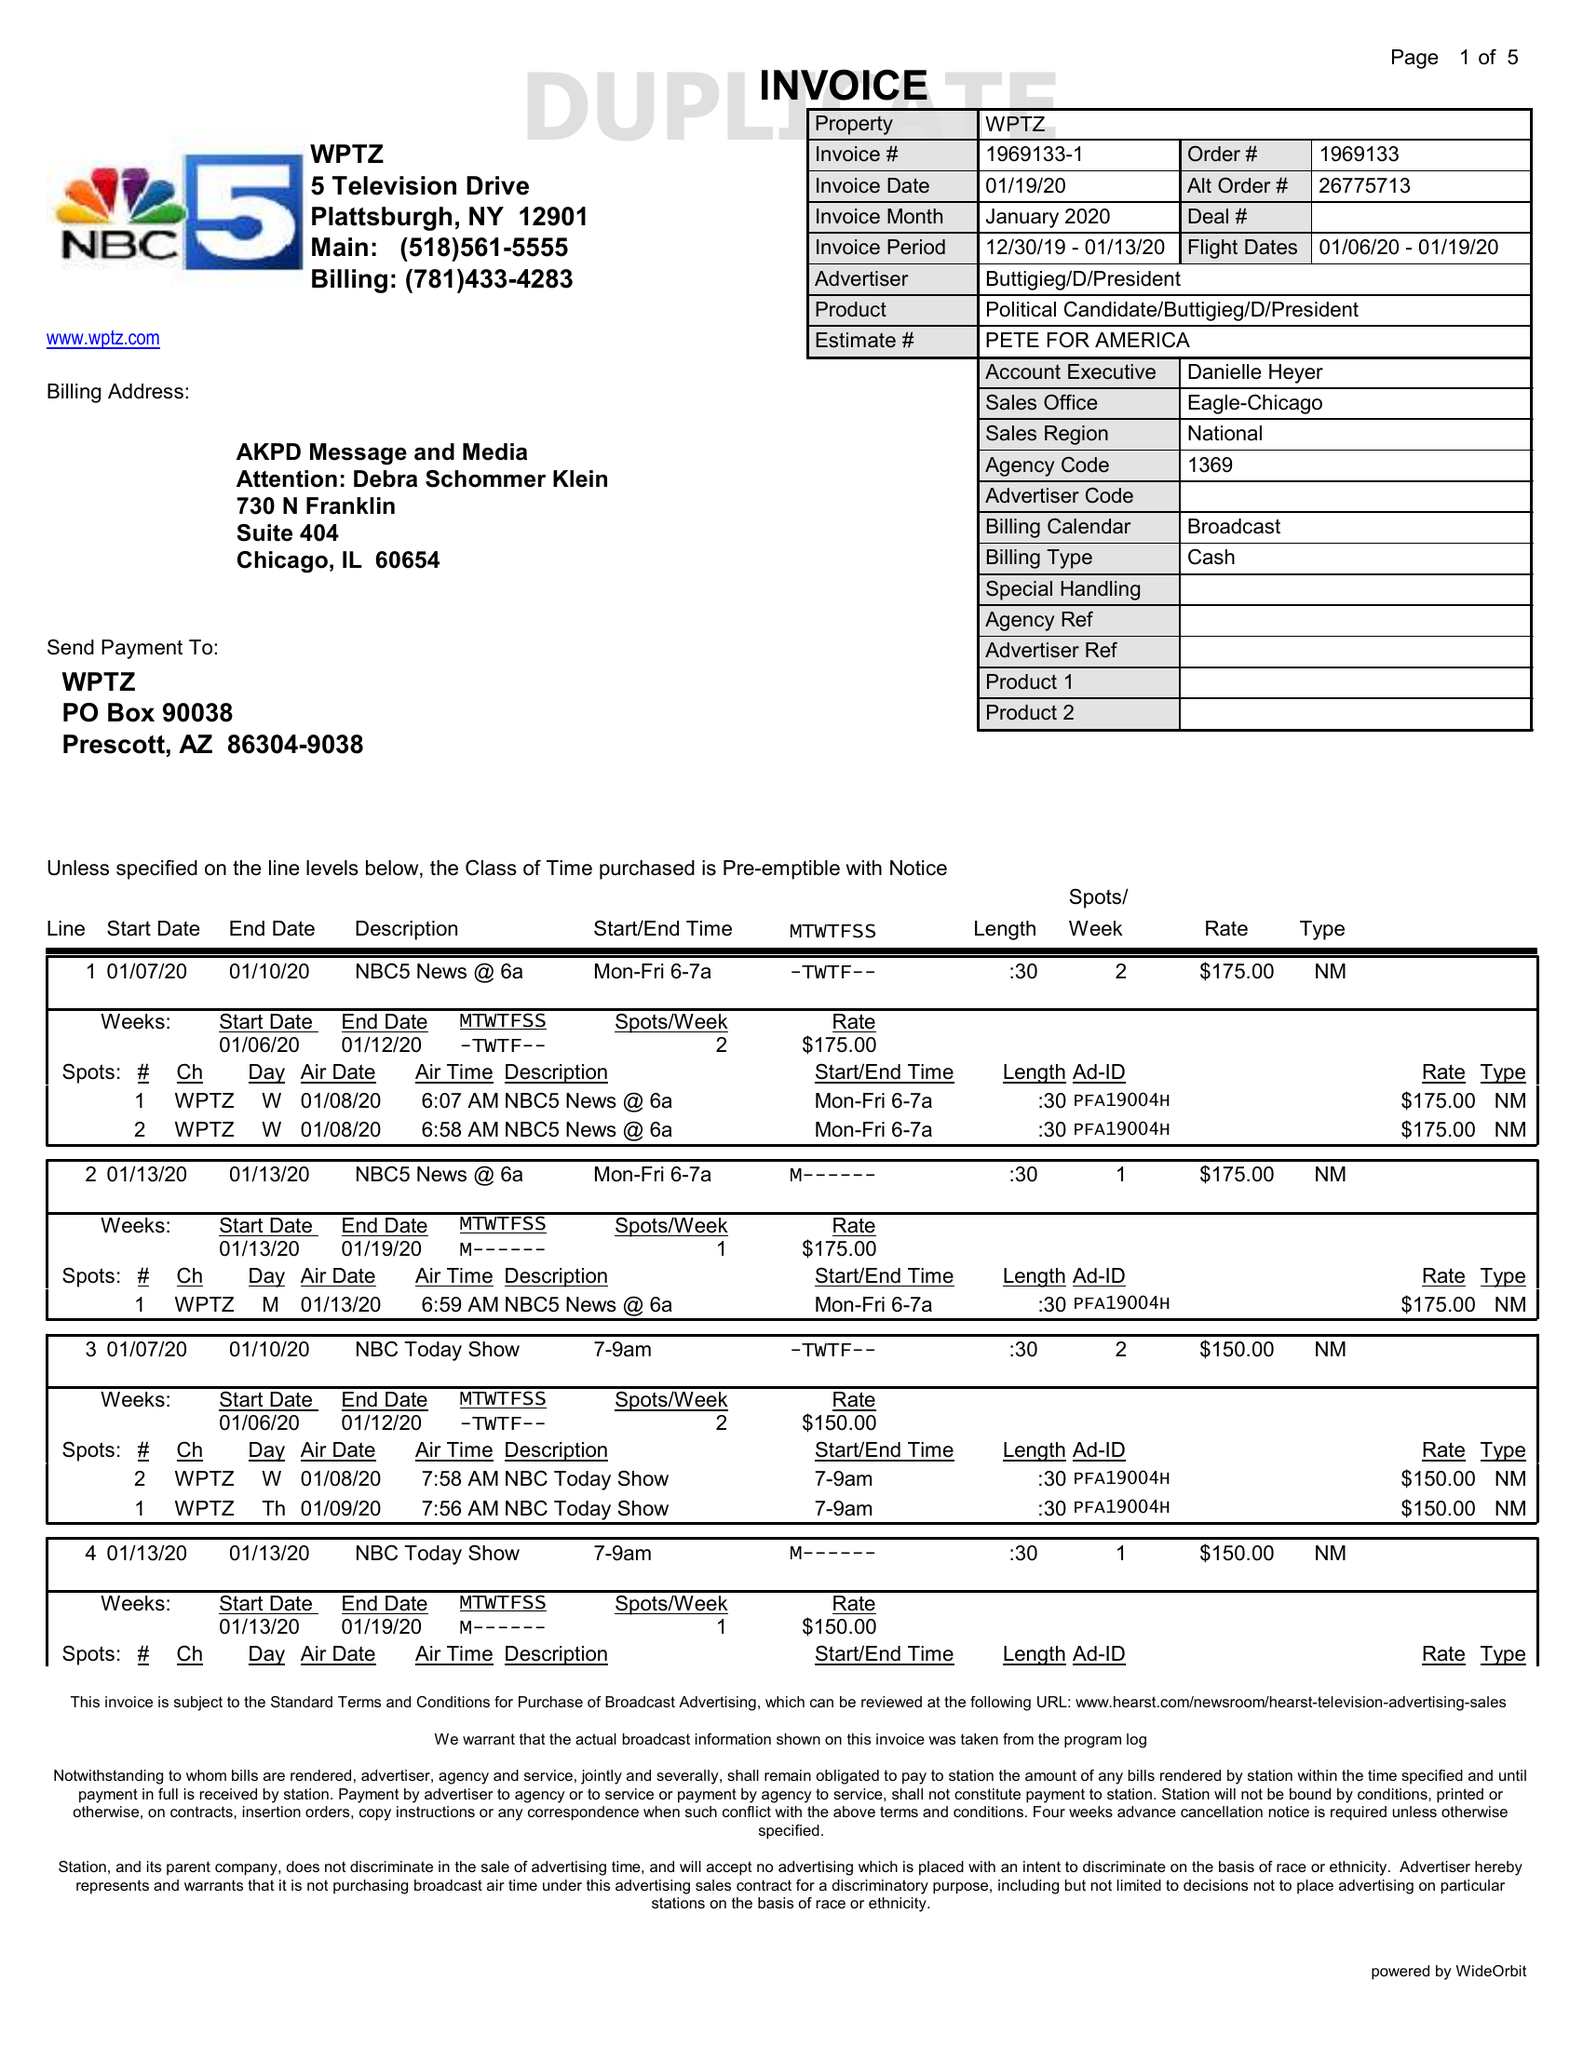What is the value for the gross_amount?
Answer the question using a single word or phrase. 8220.00 